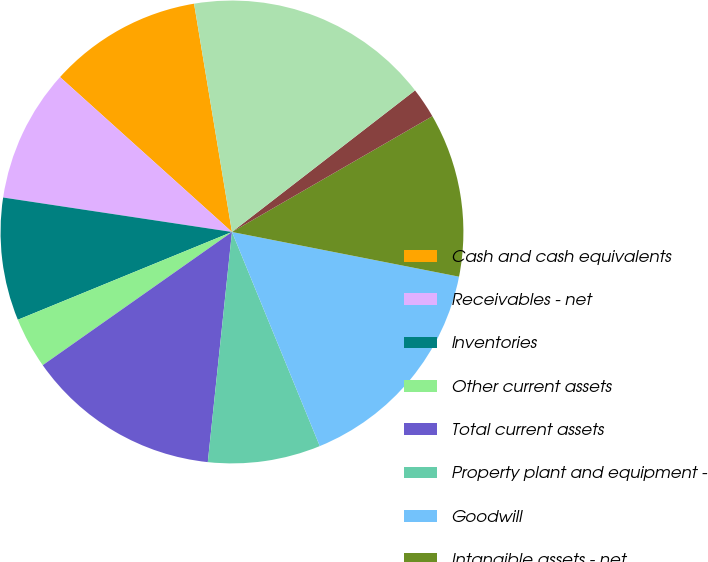Convert chart to OTSL. <chart><loc_0><loc_0><loc_500><loc_500><pie_chart><fcel>Cash and cash equivalents<fcel>Receivables - net<fcel>Inventories<fcel>Other current assets<fcel>Total current assets<fcel>Property plant and equipment -<fcel>Goodwill<fcel>Intangible assets - net<fcel>Other noncurrent assets<fcel>Total assets<nl><fcel>10.71%<fcel>9.29%<fcel>8.57%<fcel>3.57%<fcel>13.57%<fcel>7.86%<fcel>15.71%<fcel>11.43%<fcel>2.14%<fcel>17.14%<nl></chart> 